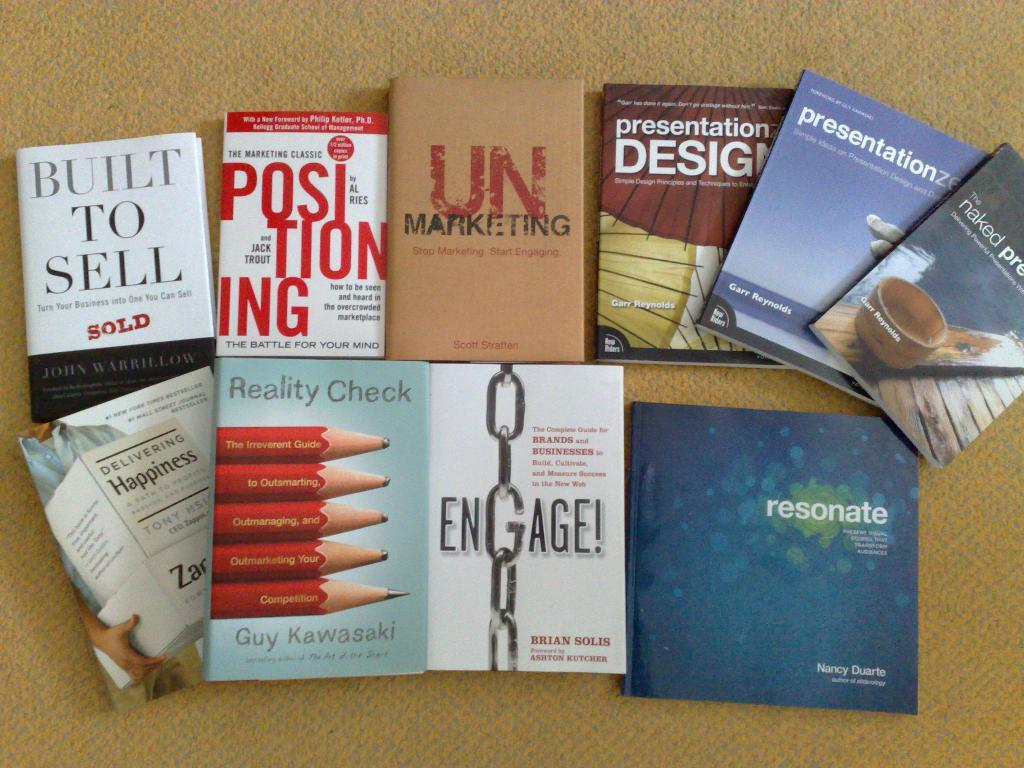<image>
Write a terse but informative summary of the picture. A pile of books laying on a table with titles like Built to Sell and Reality Check. 